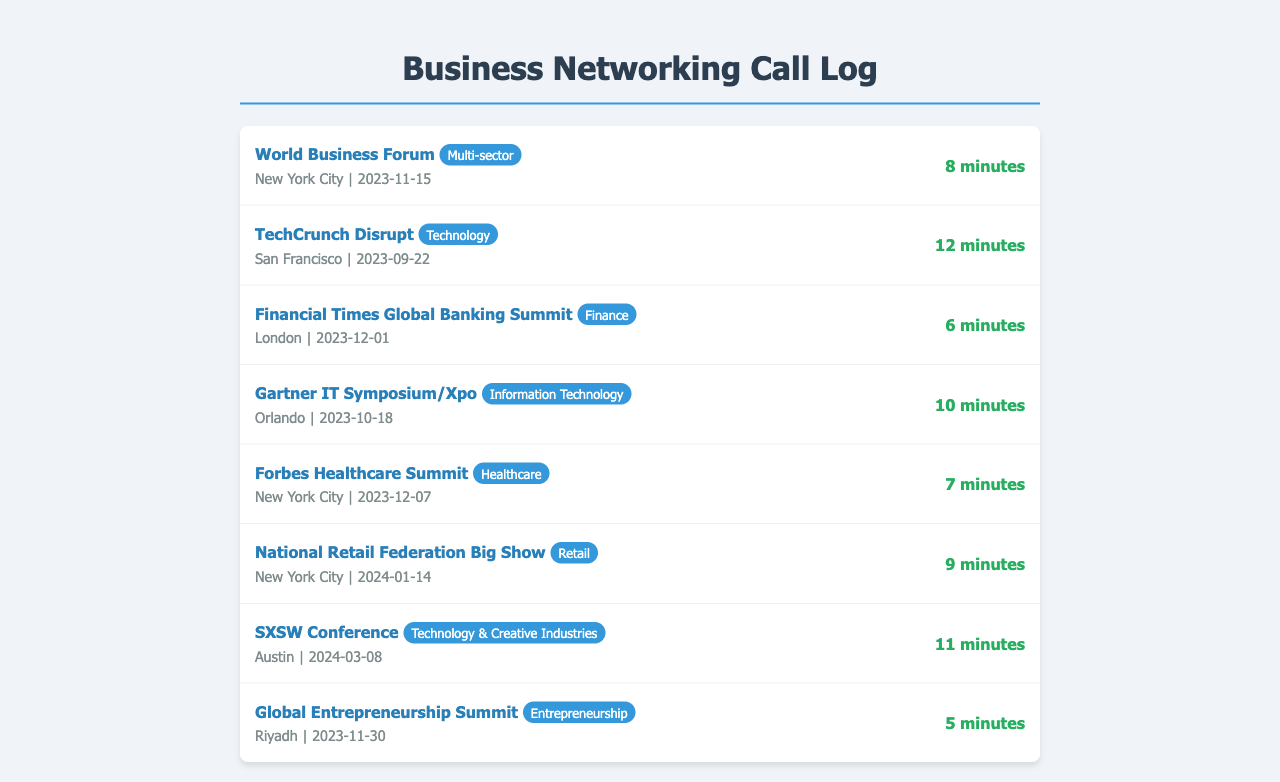What is the date of the World Business Forum? The World Business Forum is scheduled to take place on November 15, 2023.
Answer: November 15, 2023 How long was the call for the TechCrunch Disrupt event? The call for the TechCrunch Disrupt event lasted 12 minutes.
Answer: 12 minutes Which city will host the Financial Times Global Banking Summit? The Financial Times Global Banking Summit will be held in London.
Answer: London What industry does the SXSW Conference belong to? The SXSW Conference is categorized under Technology & Creative Industries.
Answer: Technology & Creative Industries How many minutes was the call related to the Global Entrepreneurship Summit? The call related to the Global Entrepreneurship Summit lasted 5 minutes.
Answer: 5 minutes Which event is scheduled after the Forbes Healthcare Summit? The National Retail Federation Big Show is scheduled after the Forbes Healthcare Summit.
Answer: National Retail Federation Big Show What is the event duration for the Gartner IT Symposium/Xpo? The duration of the call for the Gartner IT Symposium/Xpo is 10 minutes.
Answer: 10 minutes In which month is the National Retail Federation Big Show planned? The National Retail Federation Big Show is planned for January.
Answer: January How many events are categorized under the Technology industry? There are two events categorized as Technology: TechCrunch Disrupt and SXSW Conference.
Answer: two 